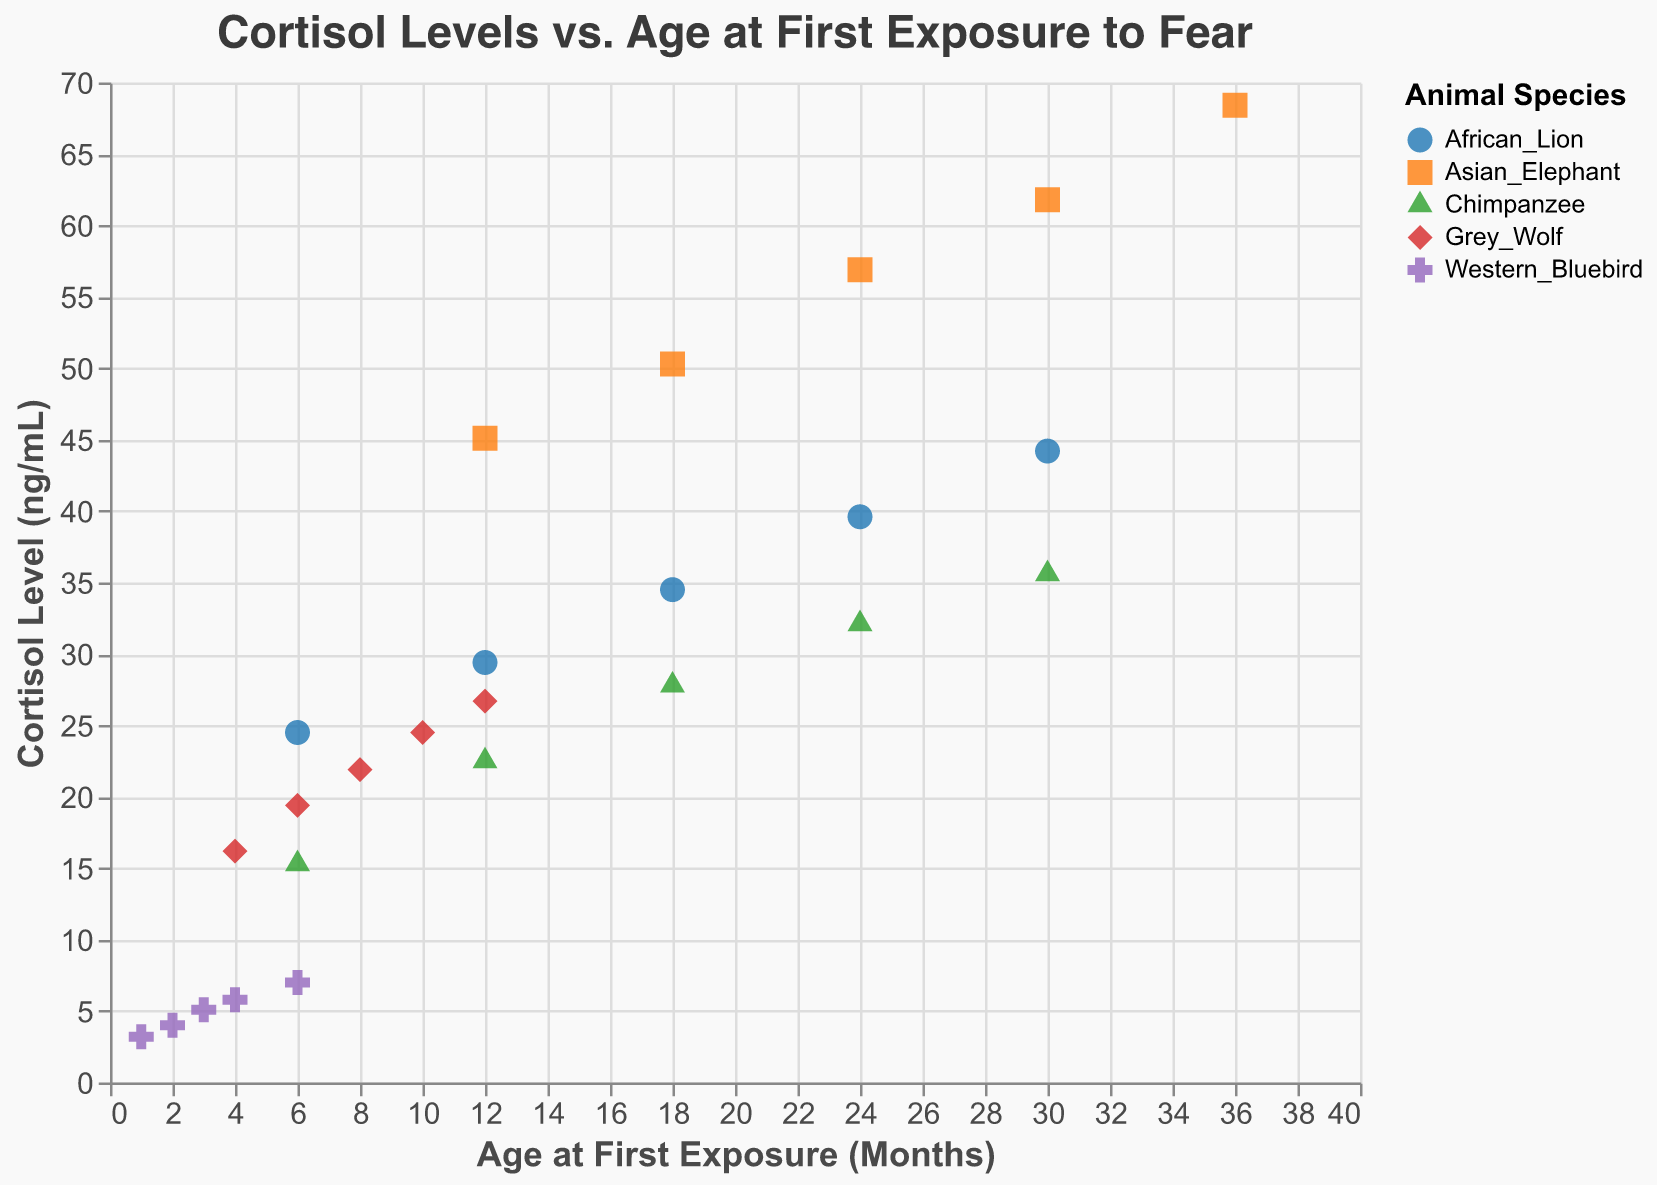What is the title of the scatter plot? The title of the scatter plot is usually displayed at the top of the figure. Here, it is written in the code under the "title" key as "Cortisol Levels vs. Age at First Exposure to Fear".
Answer: Cortisol Levels vs. Age at First Exposure to Fear Which animal species are represented in the scatter plot? The animal species are differentiated by the color and shape of the points on the scatter plot. According to the "color" and "shape" encodings, the animals listed are Chimpanzee, Western Bluebird, Asian Elephant, African Lion, and Grey Wolf.
Answer: Chimpanzee, Western Bluebird, Asian Elephant, African Lion, Grey Wolf At what age did the Asian Elephant have the highest cortisol level? The data for Asian Elephants show points for different ages and cortisol levels. According to the data, the highest cortisol level is 68.4 ng/mL at 36 months.
Answer: 36 months What is the general trend of cortisol levels as the age at first exposure increases for Chimpanzees? We can observe the trend by looking at the points for Chimpanzees. The cortisol levels increase with increasing age, indicating a positive correlation.
Answer: Increasing Which animal has the lowest cortisol level at any age, and what is that level? To find this, we look for the lowest point on the y-axis (Cortisol Level). The lowest level observed in the data is for the Western Bluebird at 1 month with a cortisol level of 3.2 ng/mL.
Answer: Western Bluebird, 3.2 ng/mL Compare the cortisol levels of Grey Wolf and African Lion at 12 months. Which has a lower cortisol level and by how much? First, identify the cortisol levels for both species at 12 months: Grey Wolf has 26.7 ng/mL and African Lion has 29.4 ng/mL. The difference is 29.4 - 26.7 = 2.7 ng/mL, with the Grey Wolf having the lower level.
Answer: Grey Wolf, 2.7 ng/mL What is the average cortisol level for Western Bluebird across the ages shown? The cortisol levels for Western Bluebirds are 3.2, 4.0, 5.1, 5.8, and 7.0 ng/mL. The average is calculated as (3.2 + 4.0 + 5.1 + 5.8 + 7.0) / 5 = 5.02 ng/mL.
Answer: 5.02 ng/mL How does the cortisol level of African Lions at 24 months compare to the Grey Wolves at 24 months? Based on the data, African Lions have a cortisol level of 39.6 ng/mL at 24 months, while Grey Wolves do not have data listed for 24 months. Therefore, only African Lions' data is available for comparison.
Answer: Not comparable Do any species show a decrease in cortisol level as the age at first exposure increases? We observe the general trend for each species. All species show an increase in cortisol level with increasing age, and none show a decrease.
Answer: No 